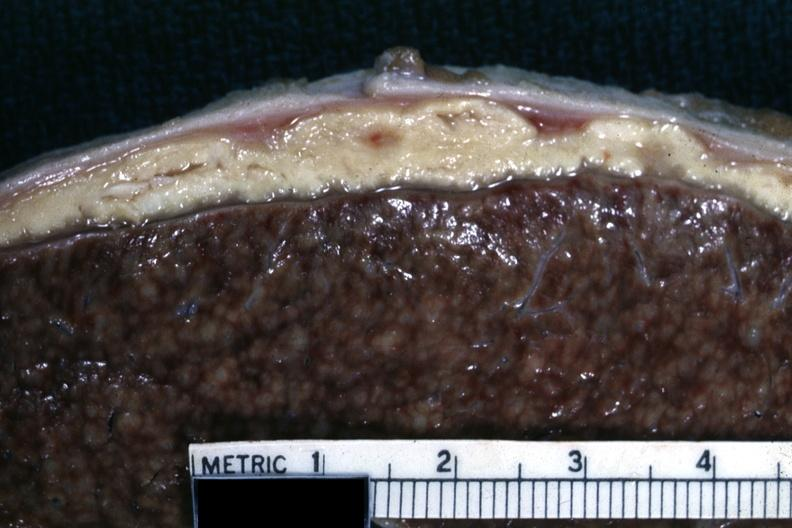does peritoneum show close-up of liver with typical gray caseous looking material that can be seen with tuberculous peritonitis?
Answer the question using a single word or phrase. No 